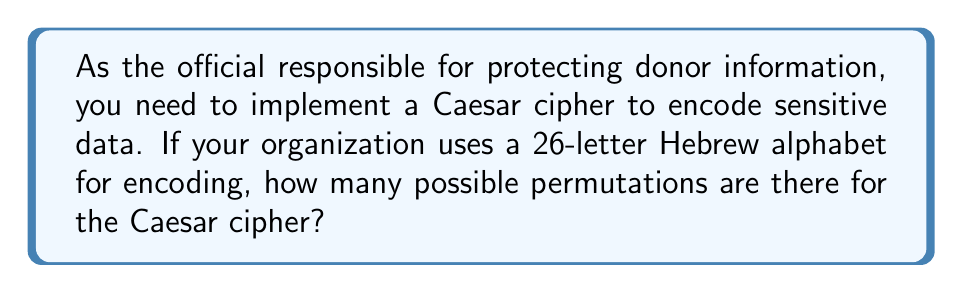Could you help me with this problem? Let's approach this step-by-step:

1) A Caesar cipher involves shifting each letter in the plaintext by a fixed number of positions in the alphabet.

2) In this case, we're using a 26-letter Hebrew alphabet.

3) The number of possible permutations is equal to the number of possible shifts.

4) We can shift the alphabet by 0 positions (which would leave the text unchanged), 1 position, 2 positions, and so on, up to 25 positions.

5) If we shift by 26 positions, we'd be back to the original alphabet, so this isn't counted as a unique permutation.

6) Therefore, the total number of possible shifts (and thus permutations) is 26.

This can be expressed mathematically as:

$$\text{Number of permutations} = |\text{Alphabet}|$$

Where $|\text{Alphabet}|$ represents the size of the alphabet.

In this case:

$$\text{Number of permutations} = 26$$
Answer: 26 